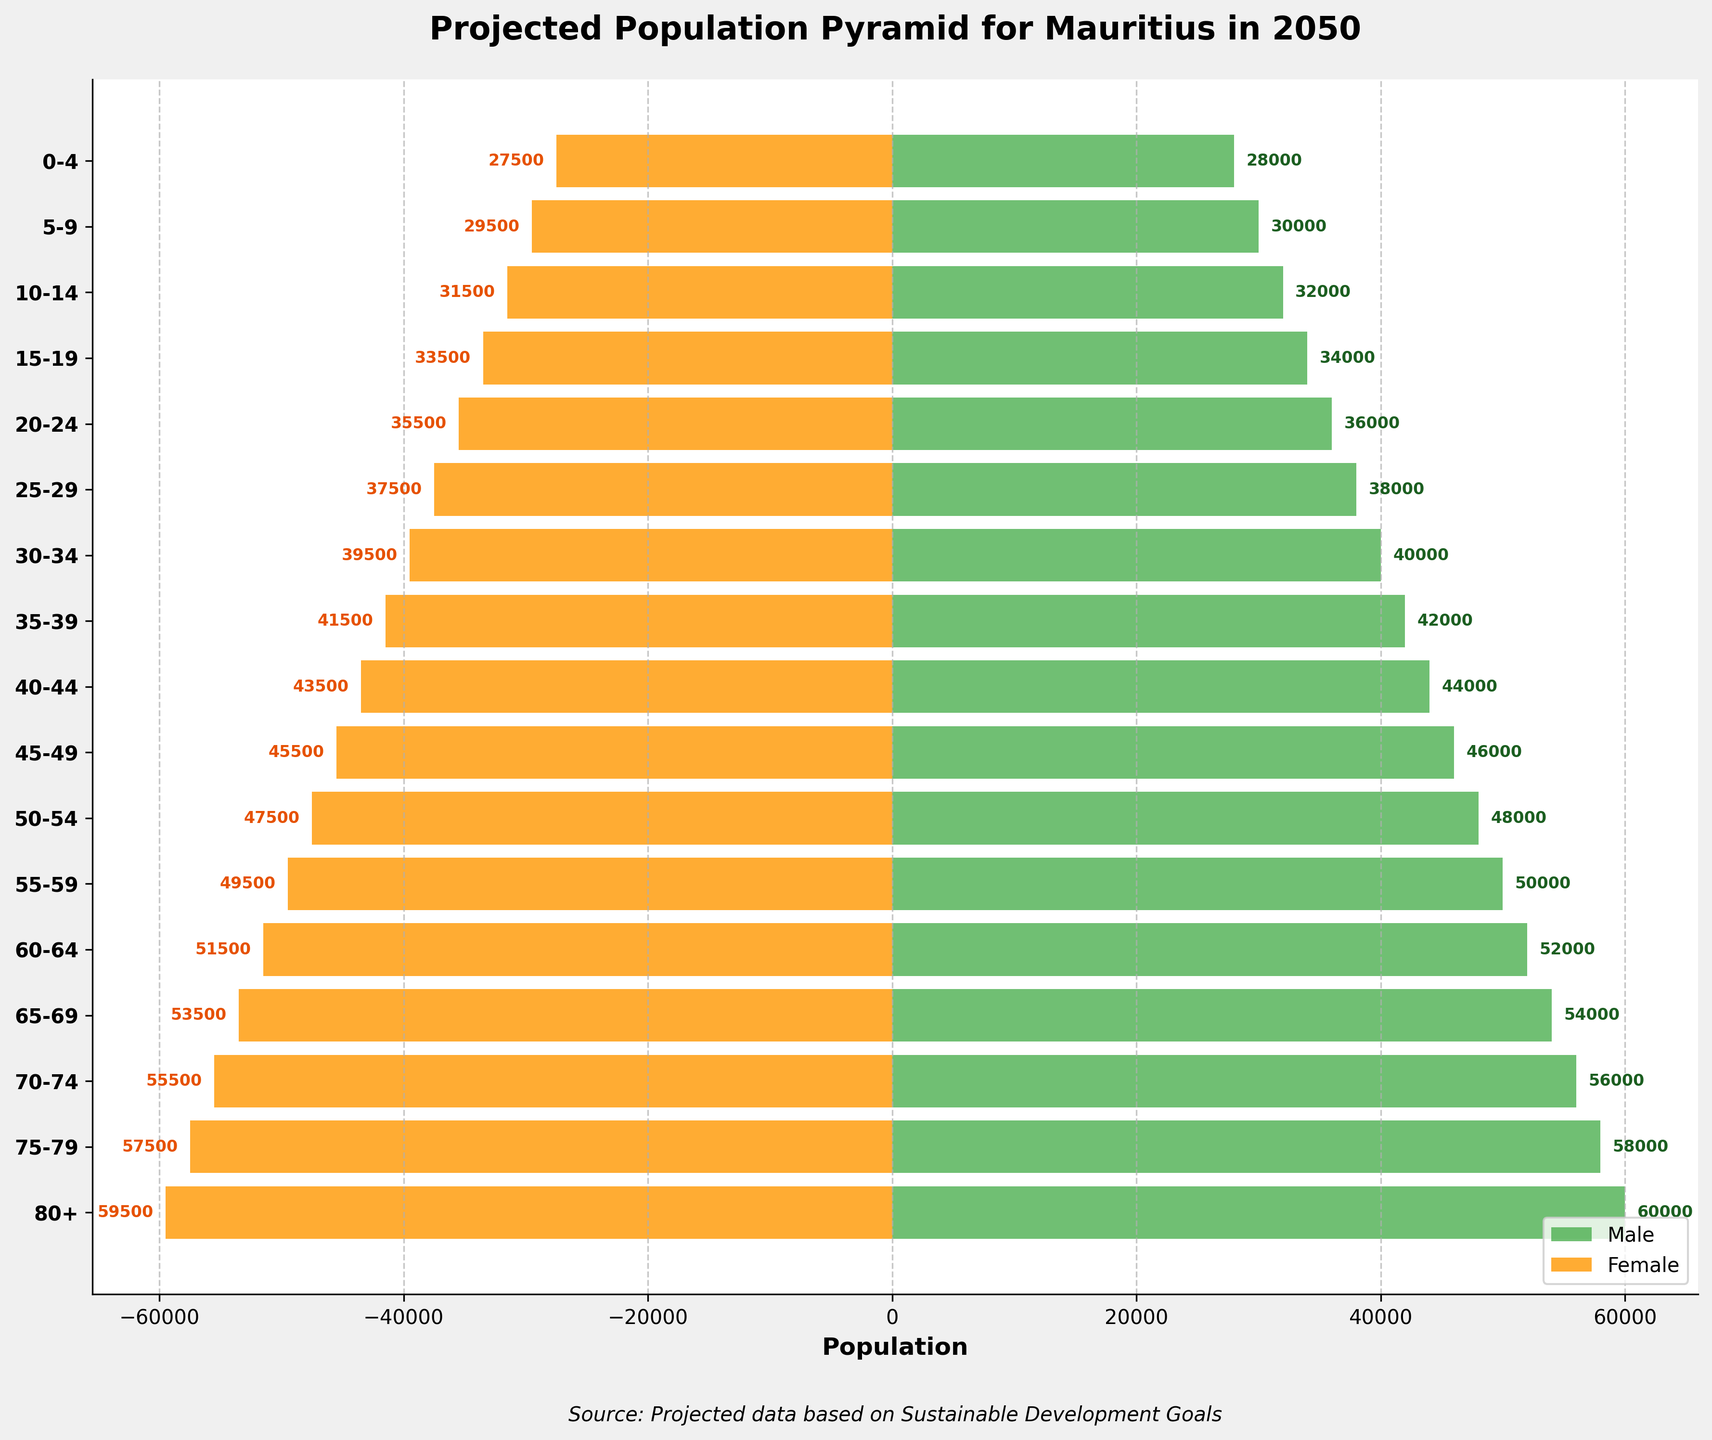What's the title of the figure? The title of the figure is displayed at the top and reads "Projected Population Pyramid for Mauritius in 2050"
Answer: Projected Population Pyramid for Mauritius in 2050 What does the color green represent in the figure? The legend at the bottom right corner indicates that the green color represents the male population.
Answer: Male population Which age group has the highest population in males? To determine this, observe the lengths of the green bars. The longest green bar corresponds to the age group 80+ with a value of 60,000.
Answer: 80+ What is the combined population of males and females in the 30-34 age group? The male population for the 30-34 age group is 40,000, and the female population is 39,500. Adding these two values gives a combined total of 79,500.
Answer: 79,500 Is the population higher for males or females in the age group 55-59? By comparing the bar lengths, the male population is 50,000, while the female population is 49,500. Therefore, the population is higher for males in this age group.
Answer: Males What is the difference in population between the ages 0-4 and 75-79 in females? The population for the 0-4 age group is 27,500, and for the 75-79 age group, it is 57,500. The difference is 57,500 - 27,500 = 30,000.
Answer: 30,000 How does the population trend vary across age groups for males? Observing the green bars starting from age group 0-4 to 80+, the population increases steadily from 0-4 (28,000) to 80+ (60,000).
Answer: Steady increase Which gender has a higher population in the 20-24 age group? By examining the bars for the 20-24 age group, the male population is 36,000 and the female population is 35,500. The male population is slightly higher.
Answer: Male Comment on the population trend of senior citizens (age groups 65 and above) for both genders. From age 65-69 to 80+, both male and female populations show an increasing trend, reaching their peaks in the 80+ age group. This indicates an aging population.
Answer: Increasing Between ages 15-19 and 40-44, which age group has a lower female population? Comparing the bars, the female population for 15-19 is 33,500 and for 40-44 is 43,500. Therefore, the 15-19 age group has a lower female population.
Answer: 15-19 